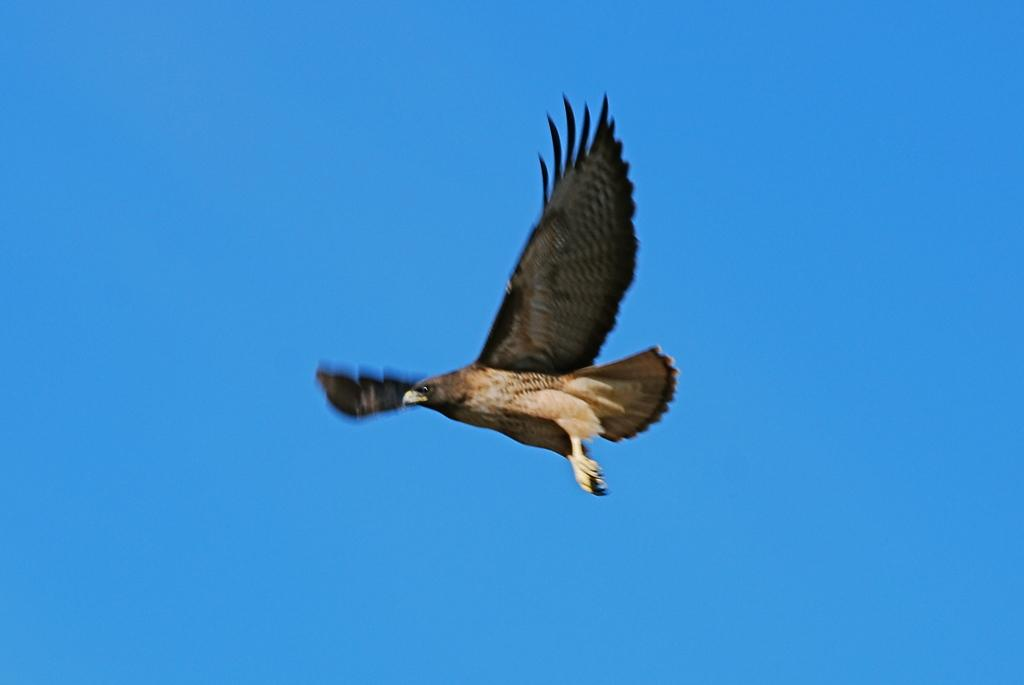What type of animal can be seen in the image? There is a bird in the image. What color is the sky in the image? The sky in the image is blue. Is there a rifle visible in the image? No, there is no rifle present in the image. What thoughts might the bird be having in the image? It is impossible to determine the thoughts of the bird in the image, as birds do not have the ability to think or express thoughts like humans. 